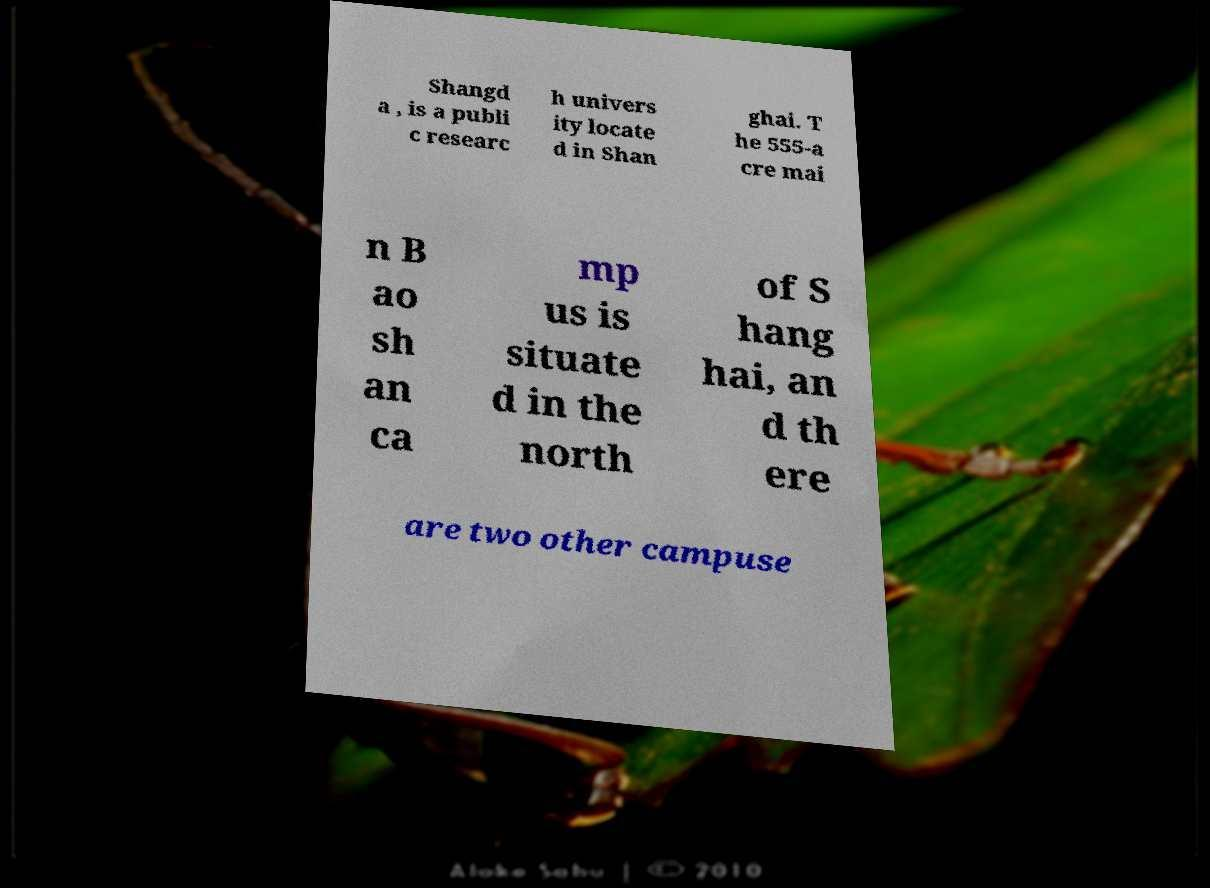Could you extract and type out the text from this image? Shangd a , is a publi c researc h univers ity locate d in Shan ghai. T he 555-a cre mai n B ao sh an ca mp us is situate d in the north of S hang hai, an d th ere are two other campuse 